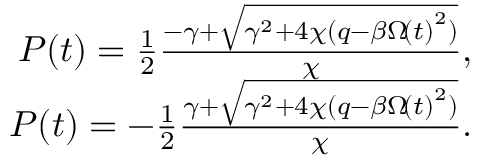<formula> <loc_0><loc_0><loc_500><loc_500>\begin{array} { r } { P \, \left ( t \right ) = \frac { 1 } { 2 } \frac { - \gamma + \sqrt { \gamma ^ { 2 } + 4 \chi ( q - \beta \Omega \, \left ( t \right ) ^ { 2 } ) } } { \chi } , } \\ { P \, \left ( t \right ) = - \frac { 1 } { 2 } \frac { \gamma + \sqrt { \gamma ^ { 2 } + 4 \chi ( q - \beta \Omega \, \left ( t \right ) ^ { 2 } ) } } { \chi } . } \end{array}</formula> 